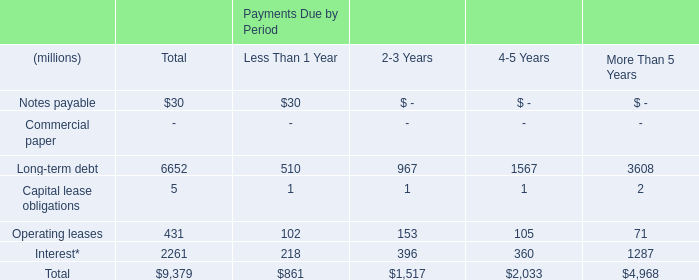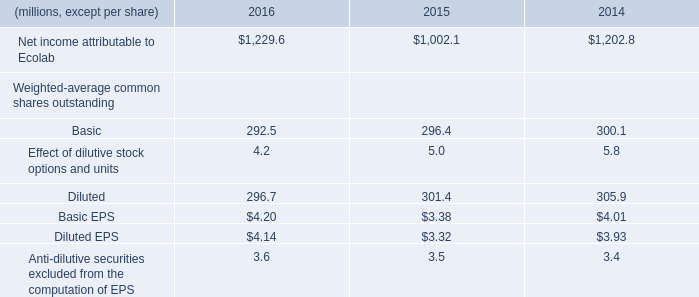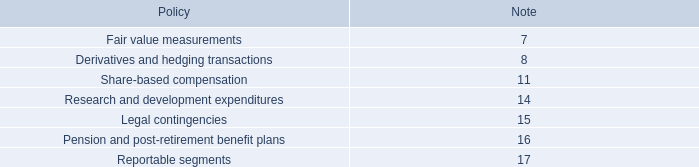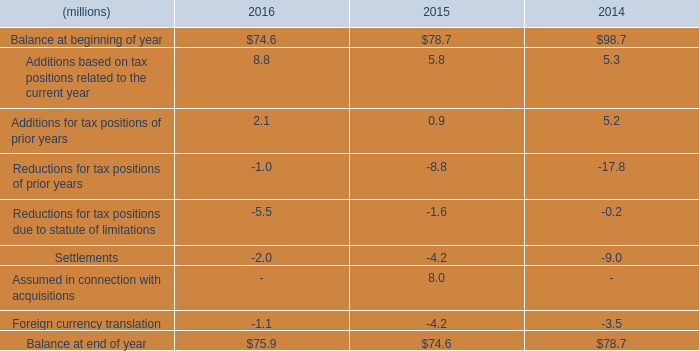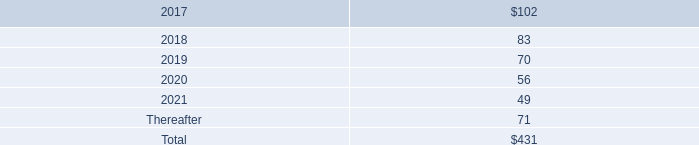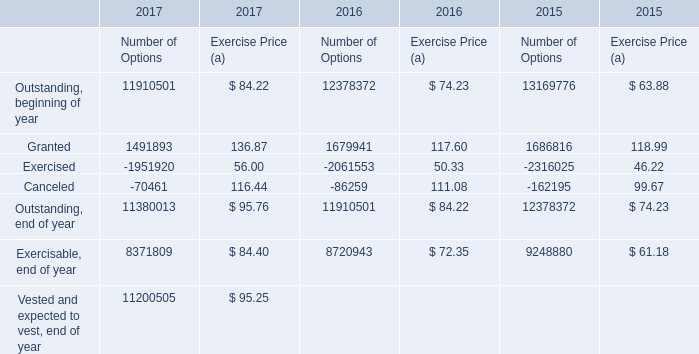What's the sum of Exercisable, end of year of 2015 Number of Options, and Interest* of Payments Due by Period More Than 5 Years ? 
Computations: (9248880.0 + 1287.0)
Answer: 9250167.0. 